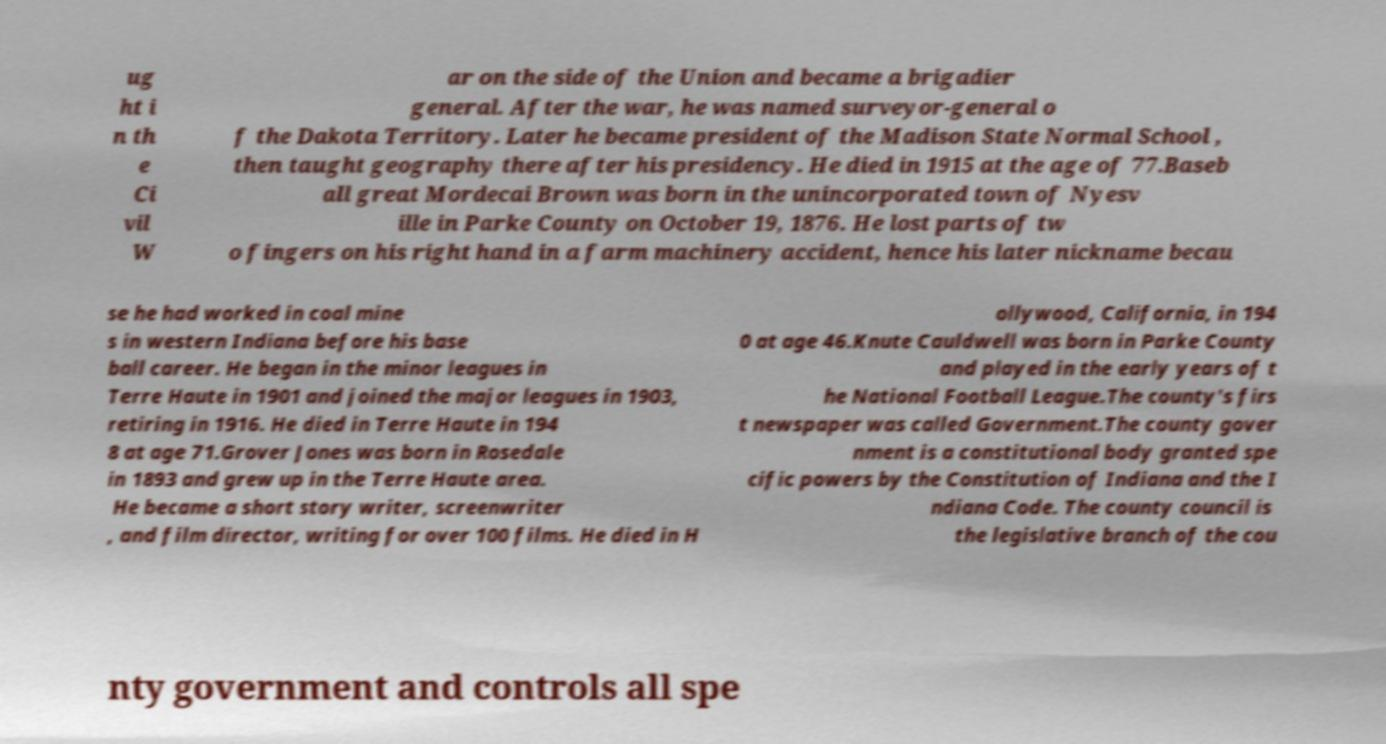What messages or text are displayed in this image? I need them in a readable, typed format. ug ht i n th e Ci vil W ar on the side of the Union and became a brigadier general. After the war, he was named surveyor-general o f the Dakota Territory. Later he became president of the Madison State Normal School , then taught geography there after his presidency. He died in 1915 at the age of 77.Baseb all great Mordecai Brown was born in the unincorporated town of Nyesv ille in Parke County on October 19, 1876. He lost parts of tw o fingers on his right hand in a farm machinery accident, hence his later nickname becau se he had worked in coal mine s in western Indiana before his base ball career. He began in the minor leagues in Terre Haute in 1901 and joined the major leagues in 1903, retiring in 1916. He died in Terre Haute in 194 8 at age 71.Grover Jones was born in Rosedale in 1893 and grew up in the Terre Haute area. He became a short story writer, screenwriter , and film director, writing for over 100 films. He died in H ollywood, California, in 194 0 at age 46.Knute Cauldwell was born in Parke County and played in the early years of t he National Football League.The county's firs t newspaper was called Government.The county gover nment is a constitutional body granted spe cific powers by the Constitution of Indiana and the I ndiana Code. The county council is the legislative branch of the cou nty government and controls all spe 